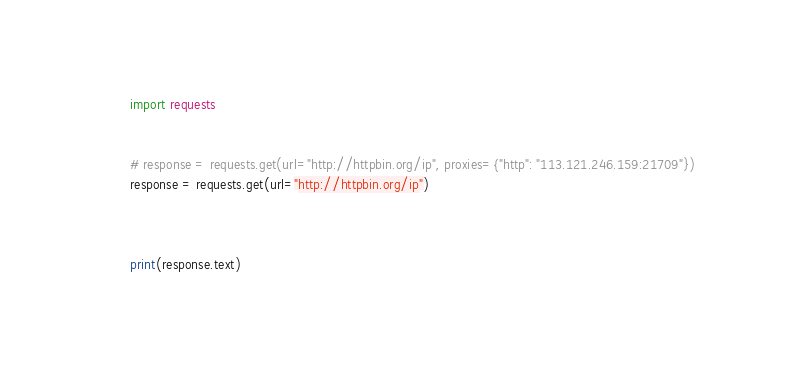Convert code to text. <code><loc_0><loc_0><loc_500><loc_500><_Python_>import requests


# response = requests.get(url="http://httpbin.org/ip", proxies={"http": "113.121.246.159:21709"})
response = requests.get(url="http://httpbin.org/ip")



print(response.text)
</code> 